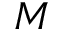<formula> <loc_0><loc_0><loc_500><loc_500>M</formula> 